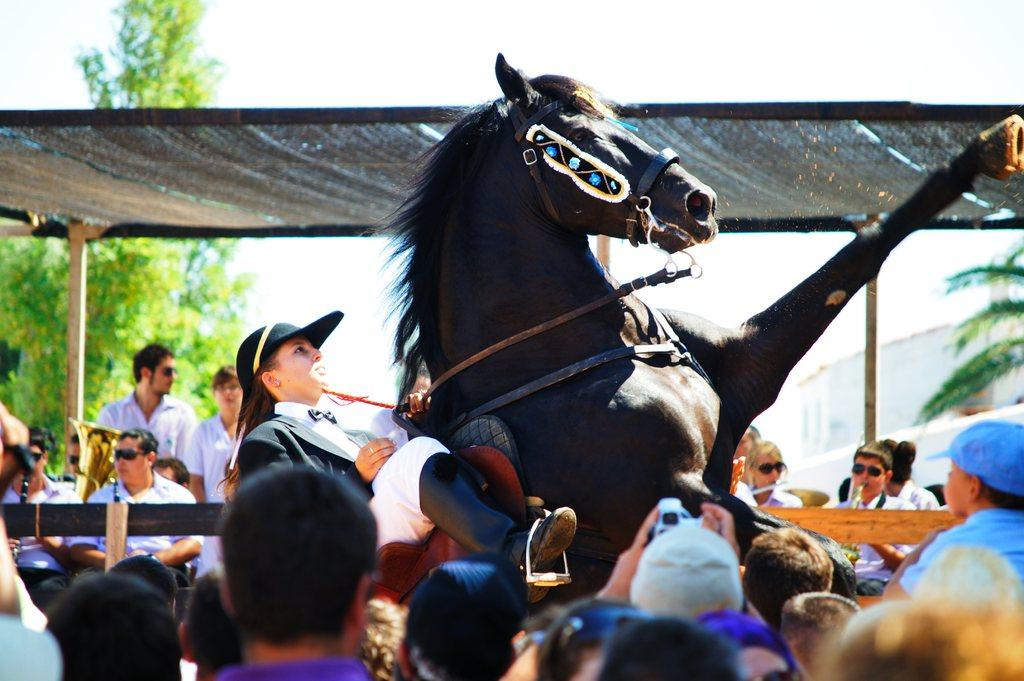What is the main subject in the middle of the image? There is a group of people in the middle of the image. What activity is happening in the background of the image? A woman is riding a horse in the background. What structures can be seen in the background of the image? There is a tent and a building in the background. What type of natural environment is visible in the background of the image? There are trees in the background. What type of government is depicted in the image? There is no depiction of a government in the image; it features a group of people, a woman riding a horse, a tent, a building, and trees. 